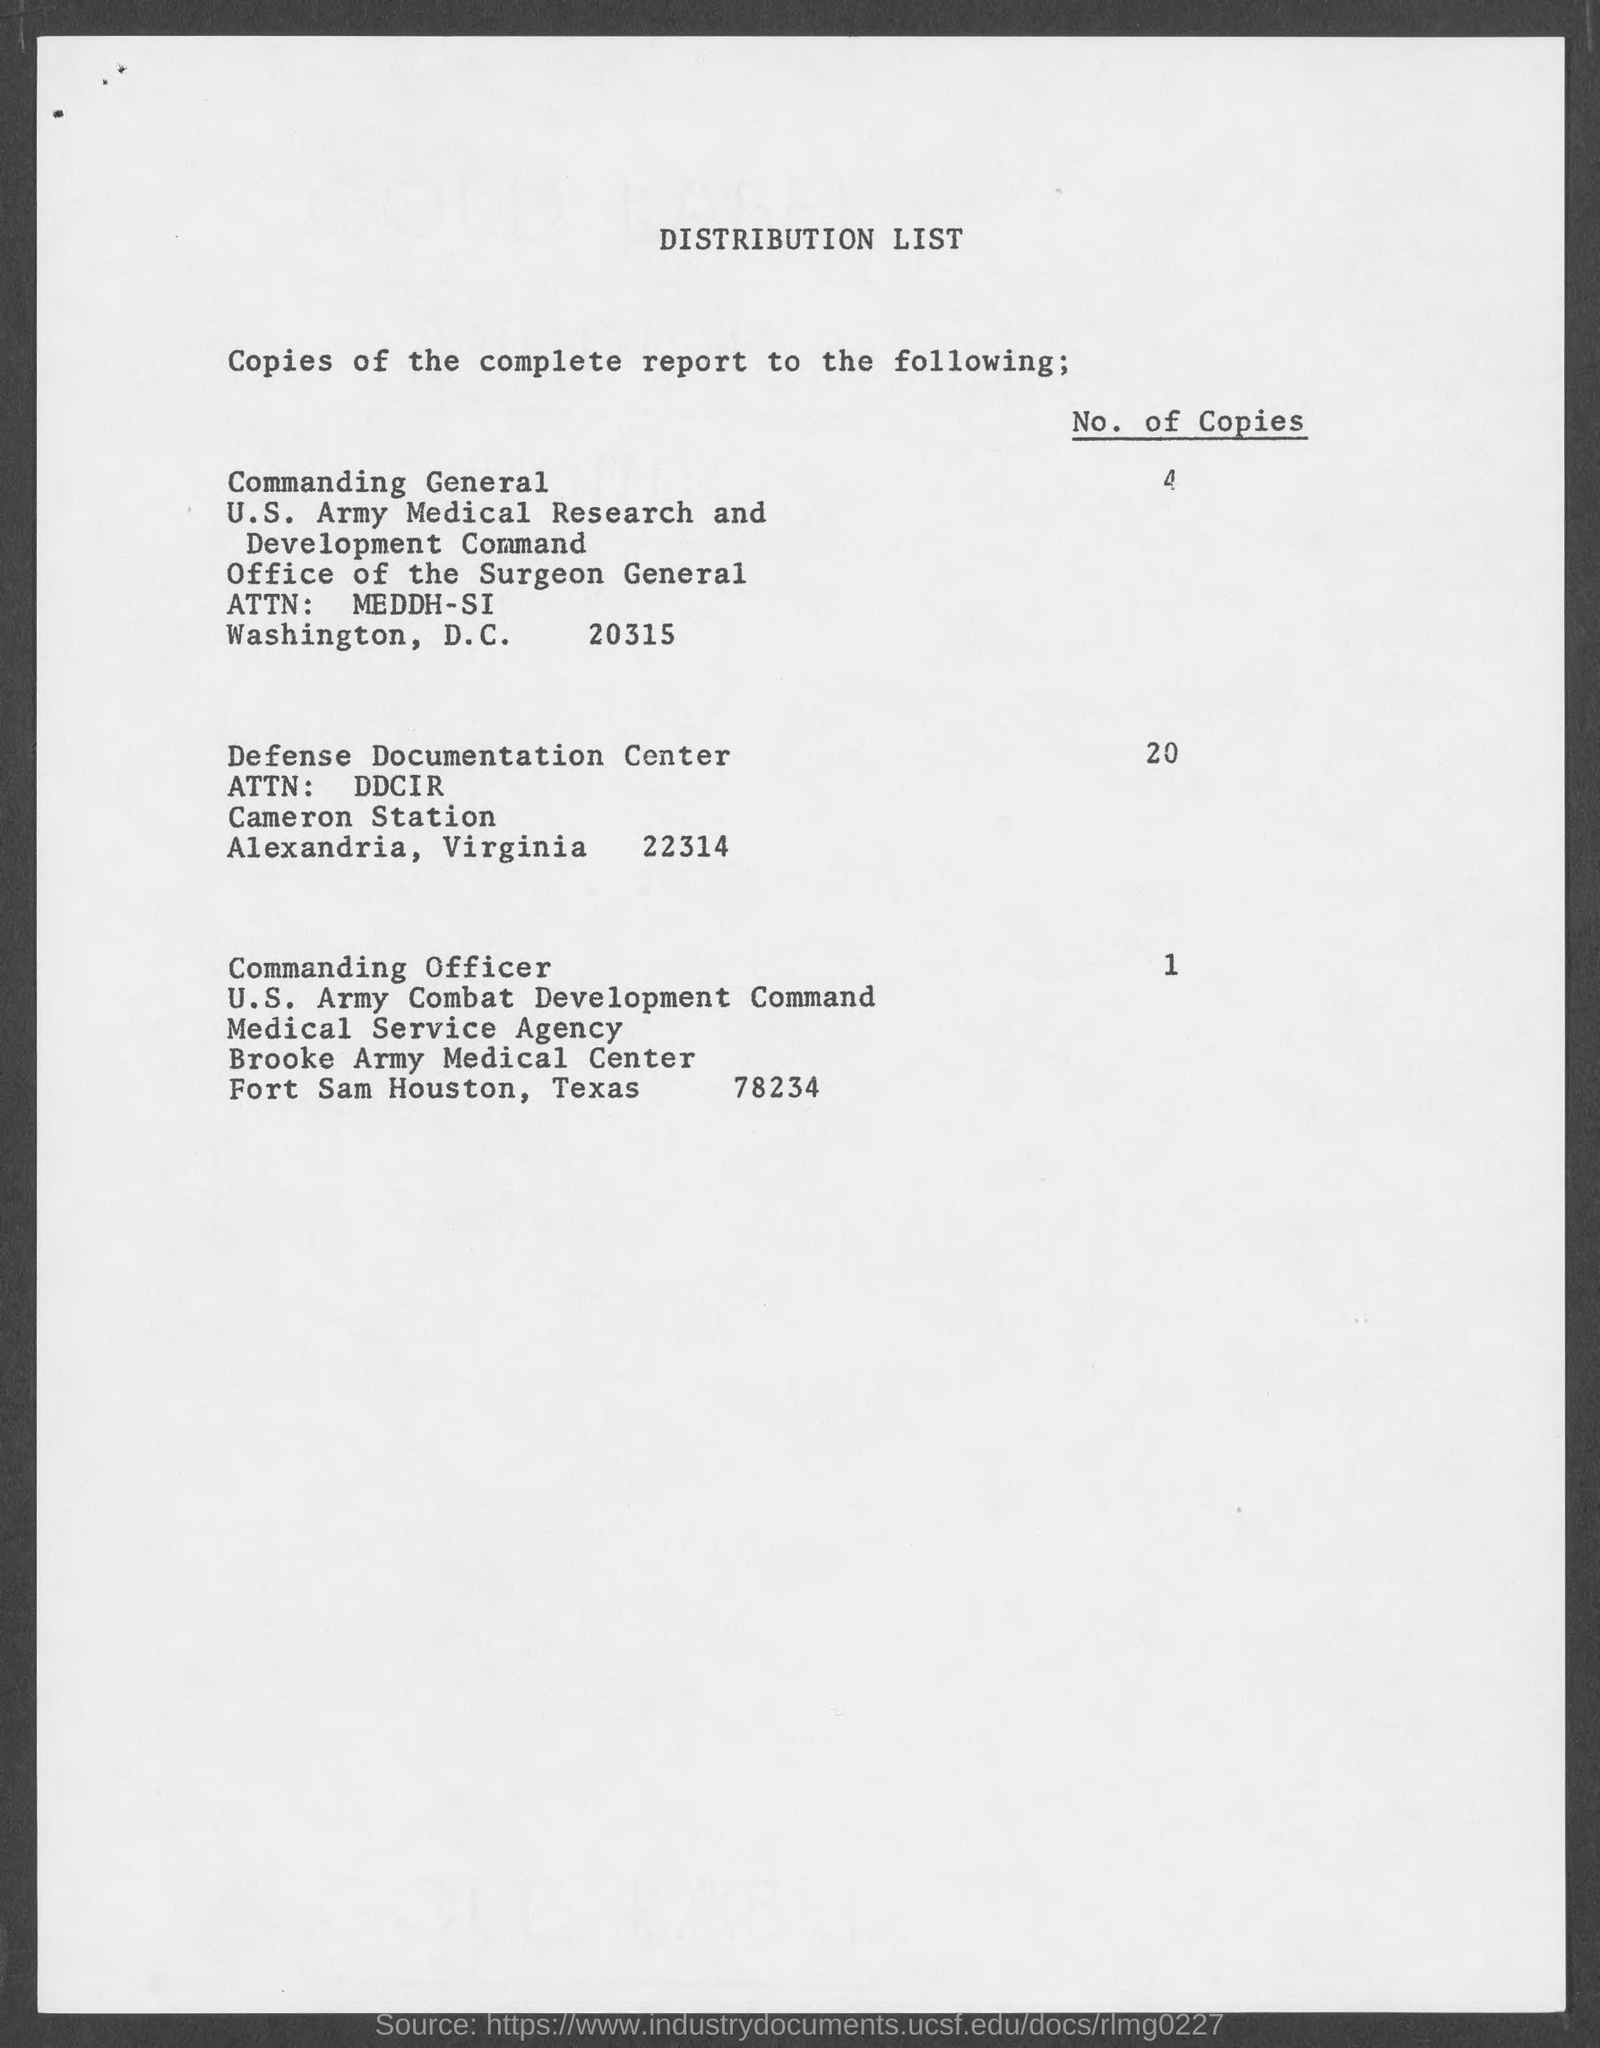How many organizations are mentioned in the distribution list of the document? Three organizations are mentioned in the distribution list of the document. 